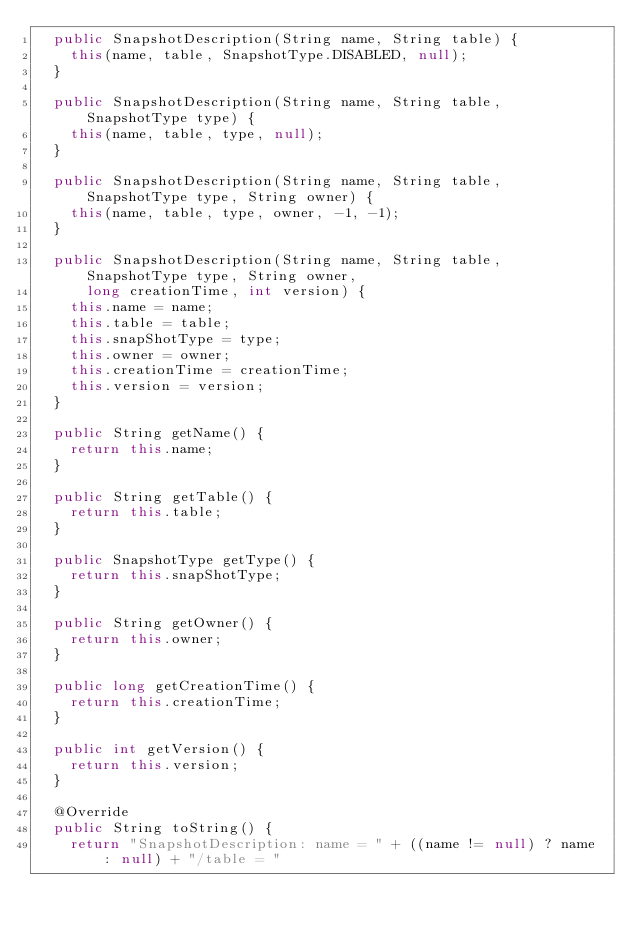Convert code to text. <code><loc_0><loc_0><loc_500><loc_500><_Java_>  public SnapshotDescription(String name, String table) {
    this(name, table, SnapshotType.DISABLED, null);
  }

  public SnapshotDescription(String name, String table, SnapshotType type) {
    this(name, table, type, null);
  }

  public SnapshotDescription(String name, String table, SnapshotType type, String owner) {
    this(name, table, type, owner, -1, -1);
  }

  public SnapshotDescription(String name, String table, SnapshotType type, String owner,
      long creationTime, int version) {
    this.name = name;
    this.table = table;
    this.snapShotType = type;
    this.owner = owner;
    this.creationTime = creationTime;
    this.version = version;
  }

  public String getName() {
    return this.name;
  }

  public String getTable() {
    return this.table;
  }

  public SnapshotType getType() {
    return this.snapShotType;
  }

  public String getOwner() {
    return this.owner;
  }

  public long getCreationTime() {
    return this.creationTime;
  }

  public int getVersion() {
    return this.version;
  }

  @Override
  public String toString() {
    return "SnapshotDescription: name = " + ((name != null) ? name : null) + "/table = "</code> 